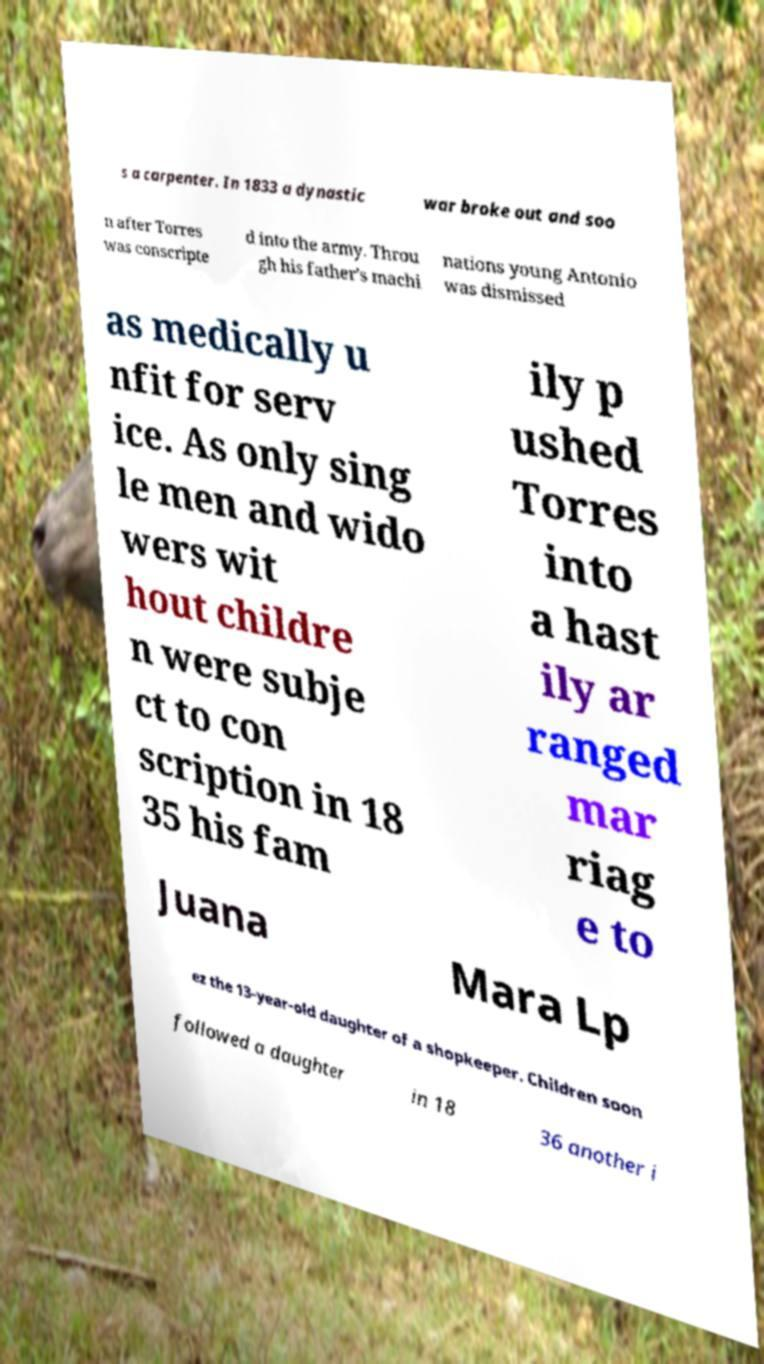There's text embedded in this image that I need extracted. Can you transcribe it verbatim? s a carpenter. In 1833 a dynastic war broke out and soo n after Torres was conscripte d into the army. Throu gh his father's machi nations young Antonio was dismissed as medically u nfit for serv ice. As only sing le men and wido wers wit hout childre n were subje ct to con scription in 18 35 his fam ily p ushed Torres into a hast ily ar ranged mar riag e to Juana Mara Lp ez the 13-year-old daughter of a shopkeeper. Children soon followed a daughter in 18 36 another i 